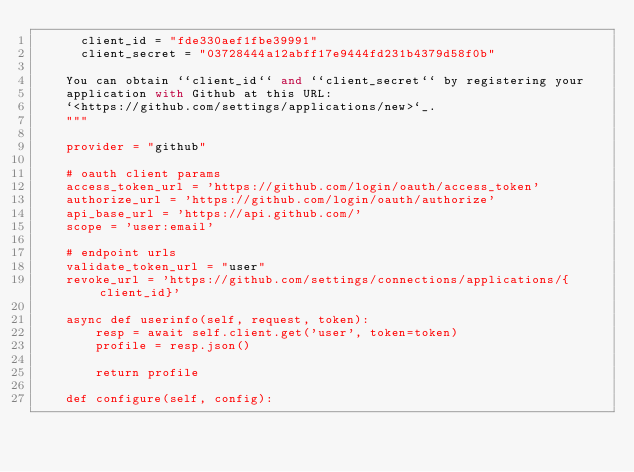Convert code to text. <code><loc_0><loc_0><loc_500><loc_500><_Python_>      client_id = "fde330aef1fbe39991"
      client_secret = "03728444a12abff17e9444fd231b4379d58f0b"

    You can obtain ``client_id`` and ``client_secret`` by registering your
    application with Github at this URL:
    `<https://github.com/settings/applications/new>`_.
    """

    provider = "github"

    # oauth client params
    access_token_url = 'https://github.com/login/oauth/access_token'
    authorize_url = 'https://github.com/login/oauth/authorize'
    api_base_url = 'https://api.github.com/'
    scope = 'user:email'

    # endpoint urls
    validate_token_url = "user"
    revoke_url = 'https://github.com/settings/connections/applications/{client_id}'

    async def userinfo(self, request, token):
        resp = await self.client.get('user', token=token)
        profile = resp.json()

        return profile

    def configure(self, config):</code> 